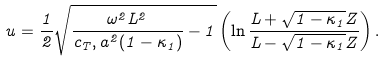Convert formula to latex. <formula><loc_0><loc_0><loc_500><loc_500>u = \frac { 1 } { 2 } \sqrt { \frac { \omega ^ { 2 } L ^ { 2 } } { c _ { T } , a ^ { 2 } ( 1 - \kappa _ { 1 } ) } - 1 } \left ( \ln \frac { L + \sqrt { 1 - \kappa _ { 1 } } Z } { L - \sqrt { 1 - \kappa _ { 1 } } Z } \right ) .</formula> 